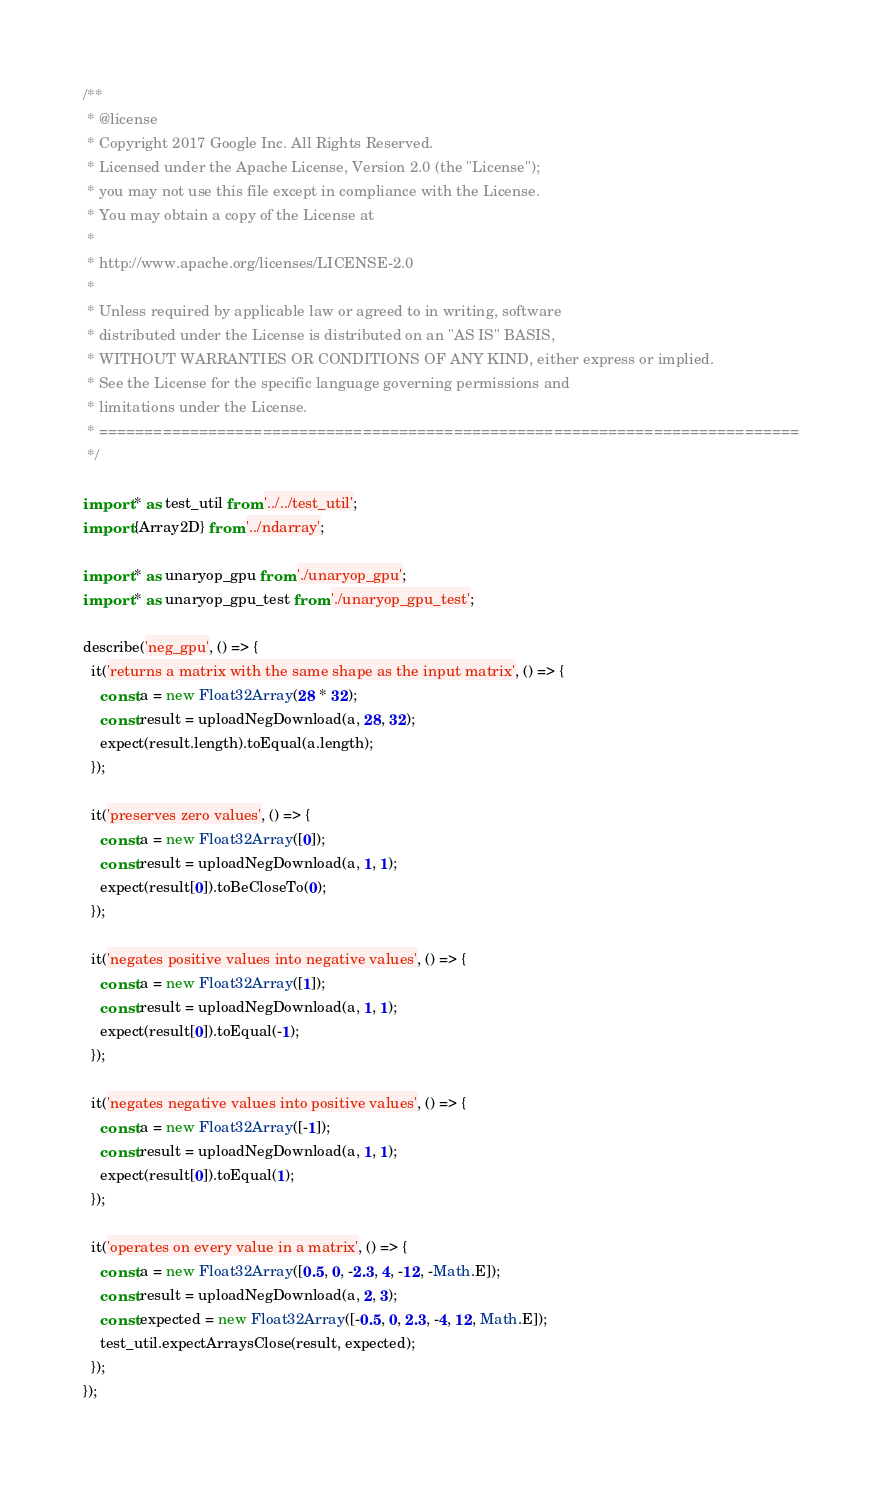<code> <loc_0><loc_0><loc_500><loc_500><_TypeScript_>/**
 * @license
 * Copyright 2017 Google Inc. All Rights Reserved.
 * Licensed under the Apache License, Version 2.0 (the "License");
 * you may not use this file except in compliance with the License.
 * You may obtain a copy of the License at
 *
 * http://www.apache.org/licenses/LICENSE-2.0
 *
 * Unless required by applicable law or agreed to in writing, software
 * distributed under the License is distributed on an "AS IS" BASIS,
 * WITHOUT WARRANTIES OR CONDITIONS OF ANY KIND, either express or implied.
 * See the License for the specific language governing permissions and
 * limitations under the License.
 * =============================================================================
 */

import * as test_util from '../../test_util';
import {Array2D} from '../ndarray';

import * as unaryop_gpu from './unaryop_gpu';
import * as unaryop_gpu_test from './unaryop_gpu_test';

describe('neg_gpu', () => {
  it('returns a matrix with the same shape as the input matrix', () => {
    const a = new Float32Array(28 * 32);
    const result = uploadNegDownload(a, 28, 32);
    expect(result.length).toEqual(a.length);
  });

  it('preserves zero values', () => {
    const a = new Float32Array([0]);
    const result = uploadNegDownload(a, 1, 1);
    expect(result[0]).toBeCloseTo(0);
  });

  it('negates positive values into negative values', () => {
    const a = new Float32Array([1]);
    const result = uploadNegDownload(a, 1, 1);
    expect(result[0]).toEqual(-1);
  });

  it('negates negative values into positive values', () => {
    const a = new Float32Array([-1]);
    const result = uploadNegDownload(a, 1, 1);
    expect(result[0]).toEqual(1);
  });

  it('operates on every value in a matrix', () => {
    const a = new Float32Array([0.5, 0, -2.3, 4, -12, -Math.E]);
    const result = uploadNegDownload(a, 2, 3);
    const expected = new Float32Array([-0.5, 0, 2.3, -4, 12, Math.E]);
    test_util.expectArraysClose(result, expected);
  });
});
</code> 